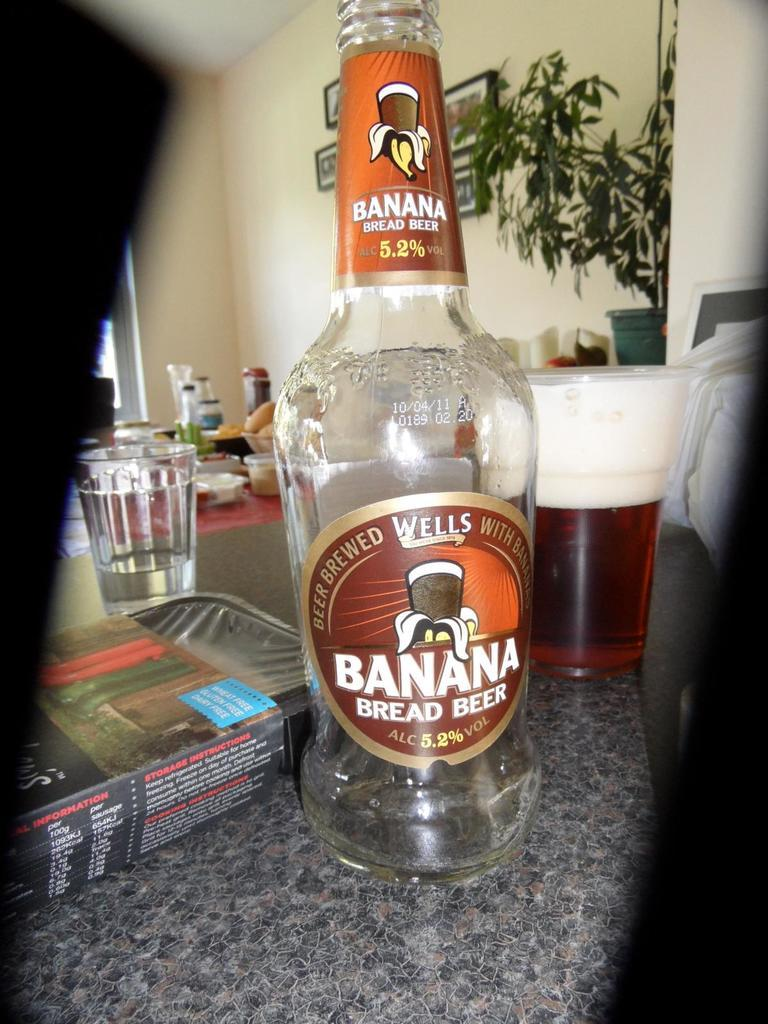<image>
Describe the image concisely. A bottle of beer has been poured from a Banana Bread Beer bottle. 